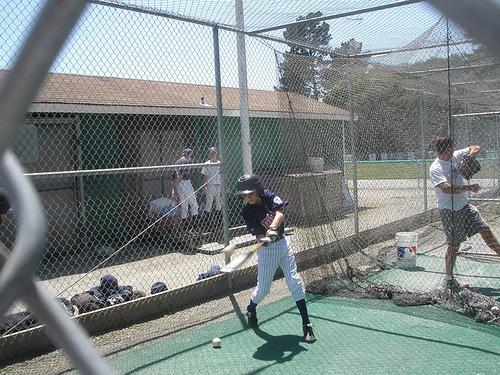What game is the boy playing?
Keep it brief. Baseball. Is this a batting cage?
Be succinct. Yes. Is it a hot day?
Answer briefly. Yes. 